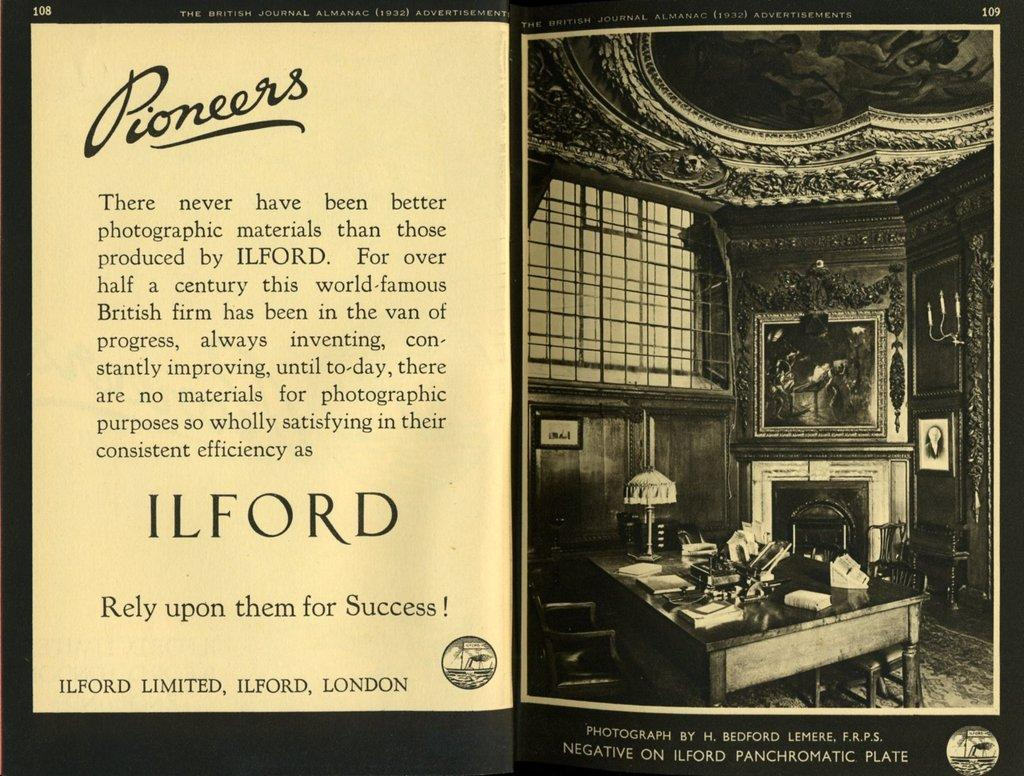<image>
Present a compact description of the photo's key features. The document talks about a place called Ilford in London. 